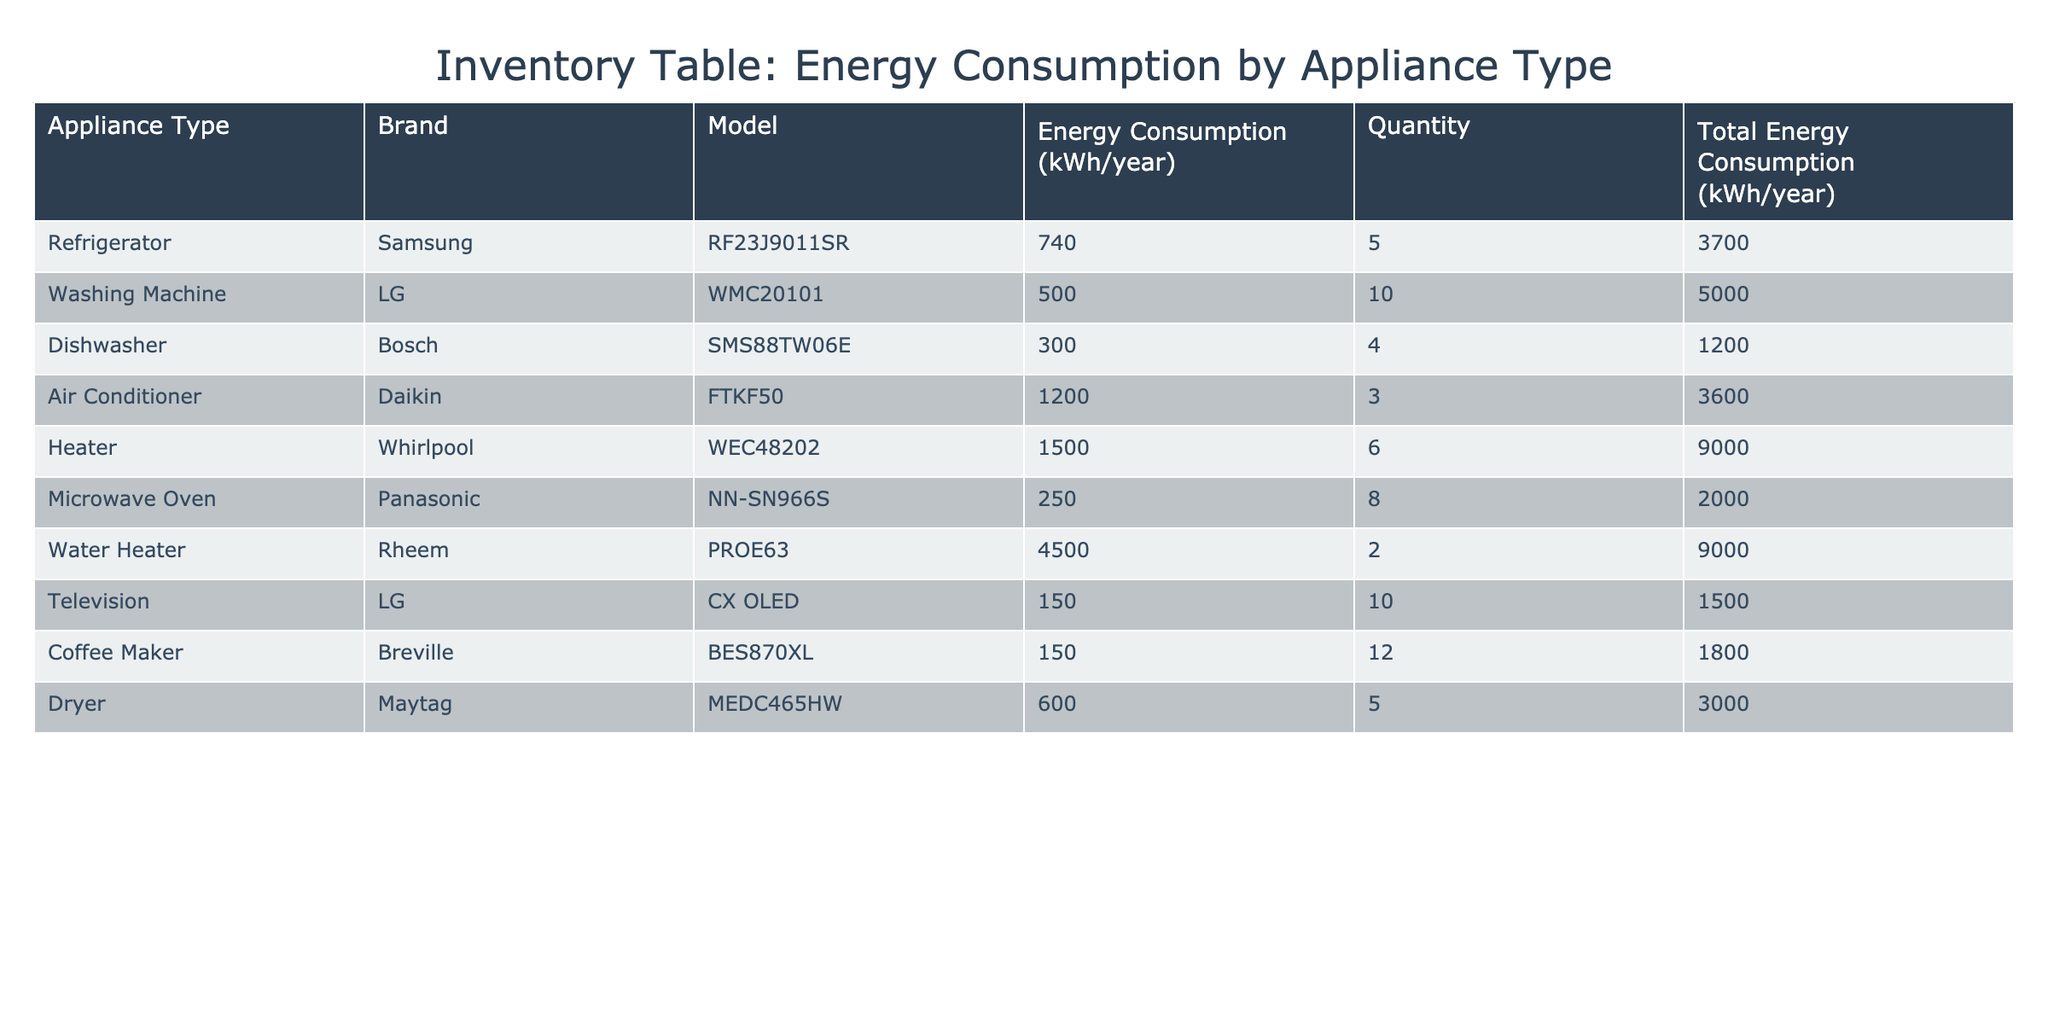What is the energy consumption of the Dishwasher? From the table, we can see under the "Energy Consumption (kWh/year)" column for the Dishwasher, it is listed as 300 kWh/year.
Answer: 300 kWh/year How many Refrigerators are in the inventory? The "Quantity" column for Refrigerators indicates there are 5 units.
Answer: 5 What is the total energy consumption for all Washing Machines? To find this, we refer to the "Total Energy Consumption (kWh/year)" for Washing Machines, which is 5000 kWh/year.
Answer: 5000 kWh/year What is the average energy consumption of all Heater and Air Conditioner appliances combined? The energy consumption of the Heater is 1500 kWh/year and the Air Conditioner is 1200 kWh/year. Adding these gives 1500 + 1200 = 2700 kWh/year. Dividing by 2 (the number of appliances) gives an average of 2700/2 = 1350 kWh/year.
Answer: 1350 kWh/year Is the energy consumption of the Coffee Maker less than the Dishwasher? The energy consumption for the Coffee Maker is 150 kWh/year and for the Dishwasher it is 300 kWh/year. Since 150 is less than 300, the statement is true.
Answer: Yes What is the total energy consumption for all appliances combined? To find this, we need to sum the "Total Energy Consumption (kWh/year)" values for all appliances: 3700 + 5000 + 1200 + 3600 + 9000 + 2000 + 9000 + 1500 + 1800 + 3000 = 19600 kWh/year.
Answer: 19600 kWh/year Which appliance type has the highest individual energy consumption, and what is its value? Looking at the "Energy Consumption (kWh/year)" column, the Water Heater has the highest value at 4500 kWh/year.
Answer: Water Heater, 4500 kWh/year How many more kWh/year does the Heater consume compared to the Microwave Oven? The Heater consumes 1500 kWh/year and the Microwave Oven consumes 250 kWh/year. The difference is 1500 - 250 = 1250 kWh/year.
Answer: 1250 kWh/year Are there more Washing Machines or Dryers in the inventory? There are 10 Washing Machines and 5 Dryers listed in the "Quantity" column. Since 10 is greater than 5, there are more Washing Machines.
Answer: Yes 